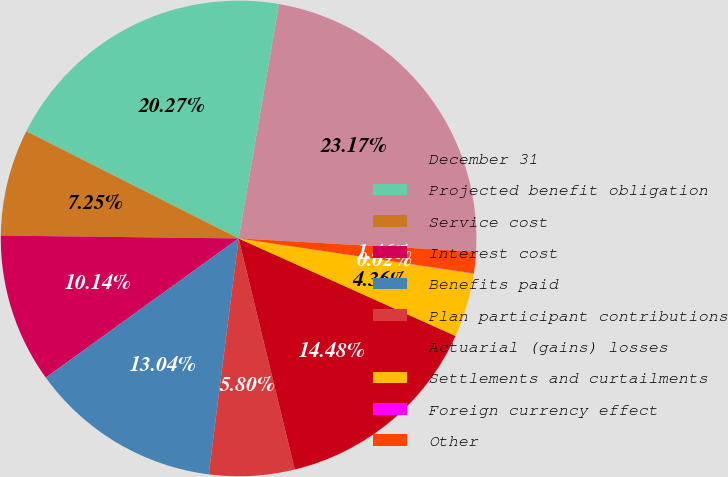Convert chart. <chart><loc_0><loc_0><loc_500><loc_500><pie_chart><fcel>December 31<fcel>Projected benefit obligation<fcel>Service cost<fcel>Interest cost<fcel>Benefits paid<fcel>Plan participant contributions<fcel>Actuarial (gains) losses<fcel>Settlements and curtailments<fcel>Foreign currency effect<fcel>Other<nl><fcel>23.17%<fcel>20.27%<fcel>7.25%<fcel>10.14%<fcel>13.04%<fcel>5.8%<fcel>14.48%<fcel>4.36%<fcel>0.02%<fcel>1.46%<nl></chart> 